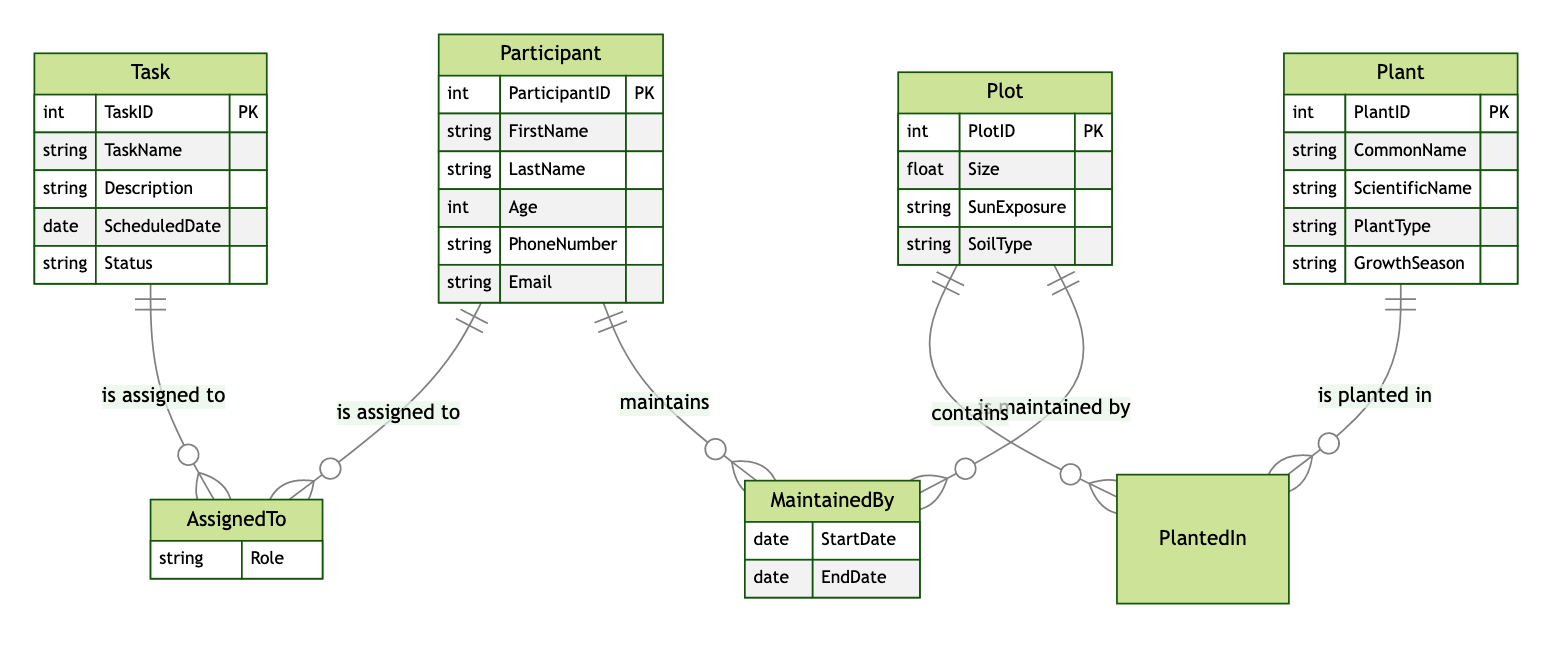What is the primary key for the Participant entity? The primary key for the Participant entity is ParticipantID, which uniquely identifies each participant in the community garden project.
Answer: ParticipantID How many entities are present in the diagram? The diagram presents four entities: Participant, Plot, Plant, and Task. This count includes all unique entities depicted.
Answer: 4 What relationship connects Task and Participant? The relationship connecting Task and Participant is called AssignedTo, indicating the tasks that participants are assigned to.
Answer: AssignedTo What attribute describes the role of a participant in a task? The attribute that describes the role of a participant in a task is Role, which is part of the AssignedTo relationship entity.
Answer: Role How many attributes are there in the Plot entity? The Plot entity has four attributes: PlotID, Size, SunExposure, and SoilType. This gives a total count of attributes in this entity.
Answer: 4 Which two entities share the MaintainedBy relationship? The two entities that share the MaintainedBy relationship are Participant and Plot, indicating which participants maintain which plots.
Answer: Participant and Plot What is the scheduled date attribute associated with? The ScheduledDate attribute is associated with the Task entity, indicating when a specific task is set to occur.
Answer: Task What does the PlantedIn relationship signify? The PlantedIn relationship signifies the connection between Plant and Plot, indicating where a particular plant is located within the community garden.
Answer: Plant and Plot What signifies the start and end of maintenance? The attributes StartDate and EndDate within the MaintainedBy relationship signify the timeline for the maintenance of a plot by a participant.
Answer: StartDate and EndDate What is the common link between Plant and Plot? The common link between Plant and Plot is the PlantedIn relationship, demonstrating that plants are planted in specific plots in the garden.
Answer: PlantedIn 